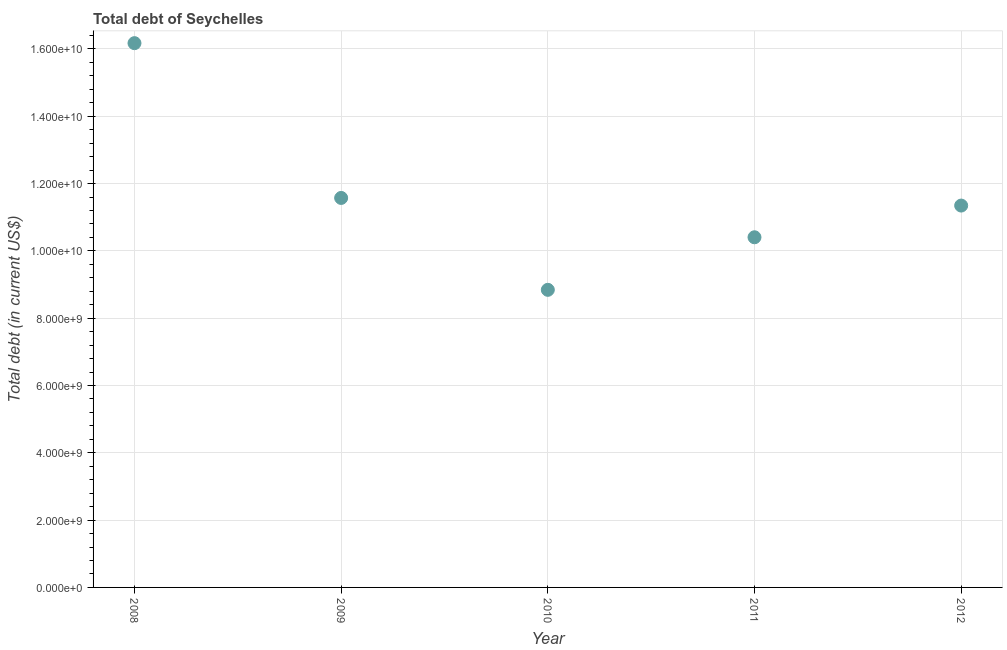What is the total debt in 2012?
Your answer should be compact. 1.13e+1. Across all years, what is the maximum total debt?
Make the answer very short. 1.62e+1. Across all years, what is the minimum total debt?
Offer a terse response. 8.84e+09. In which year was the total debt minimum?
Your answer should be very brief. 2010. What is the sum of the total debt?
Offer a terse response. 5.83e+1. What is the difference between the total debt in 2009 and 2011?
Provide a short and direct response. 1.17e+09. What is the average total debt per year?
Your response must be concise. 1.17e+1. What is the median total debt?
Ensure brevity in your answer.  1.13e+1. What is the ratio of the total debt in 2008 to that in 2011?
Keep it short and to the point. 1.55. What is the difference between the highest and the second highest total debt?
Keep it short and to the point. 4.60e+09. What is the difference between the highest and the lowest total debt?
Offer a very short reply. 7.33e+09. In how many years, is the total debt greater than the average total debt taken over all years?
Provide a short and direct response. 1. Does the total debt monotonically increase over the years?
Give a very brief answer. No. How many years are there in the graph?
Ensure brevity in your answer.  5. Does the graph contain any zero values?
Offer a very short reply. No. What is the title of the graph?
Provide a succinct answer. Total debt of Seychelles. What is the label or title of the Y-axis?
Offer a terse response. Total debt (in current US$). What is the Total debt (in current US$) in 2008?
Ensure brevity in your answer.  1.62e+1. What is the Total debt (in current US$) in 2009?
Make the answer very short. 1.16e+1. What is the Total debt (in current US$) in 2010?
Keep it short and to the point. 8.84e+09. What is the Total debt (in current US$) in 2011?
Offer a terse response. 1.04e+1. What is the Total debt (in current US$) in 2012?
Ensure brevity in your answer.  1.13e+1. What is the difference between the Total debt (in current US$) in 2008 and 2009?
Offer a terse response. 4.60e+09. What is the difference between the Total debt (in current US$) in 2008 and 2010?
Provide a succinct answer. 7.33e+09. What is the difference between the Total debt (in current US$) in 2008 and 2011?
Make the answer very short. 5.77e+09. What is the difference between the Total debt (in current US$) in 2008 and 2012?
Ensure brevity in your answer.  4.83e+09. What is the difference between the Total debt (in current US$) in 2009 and 2010?
Provide a succinct answer. 2.73e+09. What is the difference between the Total debt (in current US$) in 2009 and 2011?
Ensure brevity in your answer.  1.17e+09. What is the difference between the Total debt (in current US$) in 2009 and 2012?
Offer a terse response. 2.27e+08. What is the difference between the Total debt (in current US$) in 2010 and 2011?
Your answer should be compact. -1.56e+09. What is the difference between the Total debt (in current US$) in 2010 and 2012?
Give a very brief answer. -2.50e+09. What is the difference between the Total debt (in current US$) in 2011 and 2012?
Your answer should be very brief. -9.42e+08. What is the ratio of the Total debt (in current US$) in 2008 to that in 2009?
Offer a very short reply. 1.4. What is the ratio of the Total debt (in current US$) in 2008 to that in 2010?
Keep it short and to the point. 1.83. What is the ratio of the Total debt (in current US$) in 2008 to that in 2011?
Your answer should be compact. 1.55. What is the ratio of the Total debt (in current US$) in 2008 to that in 2012?
Provide a short and direct response. 1.43. What is the ratio of the Total debt (in current US$) in 2009 to that in 2010?
Offer a very short reply. 1.31. What is the ratio of the Total debt (in current US$) in 2009 to that in 2011?
Your answer should be very brief. 1.11. What is the ratio of the Total debt (in current US$) in 2009 to that in 2012?
Your answer should be compact. 1.02. What is the ratio of the Total debt (in current US$) in 2010 to that in 2012?
Keep it short and to the point. 0.78. What is the ratio of the Total debt (in current US$) in 2011 to that in 2012?
Give a very brief answer. 0.92. 